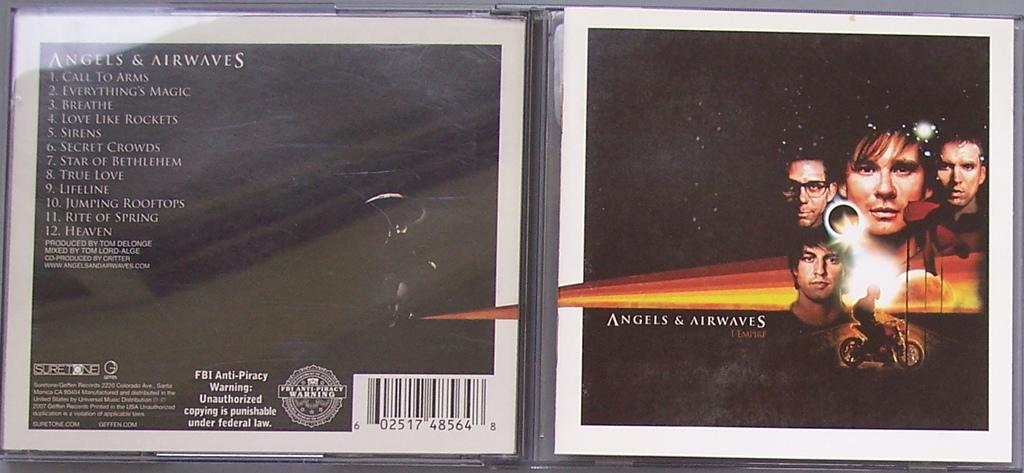<image>
Give a short and clear explanation of the subsequent image. open cd case of angels & airwaves that has picture of 4 peoples heads and guy on a motorbike 